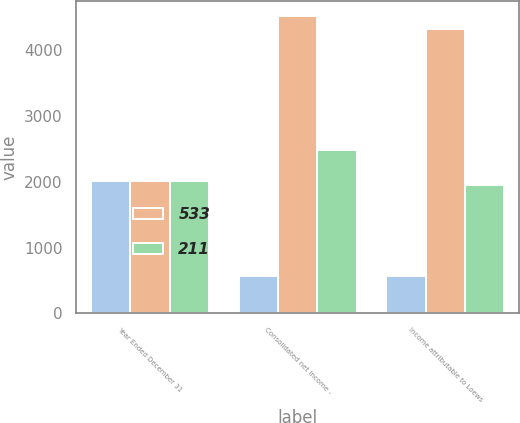<chart> <loc_0><loc_0><loc_500><loc_500><stacked_bar_chart><ecel><fcel>Year Ended December 31<fcel>Consolidated net income -<fcel>Income attributable to Loews<nl><fcel>nan<fcel>2009<fcel>564<fcel>564<nl><fcel>533<fcel>2008<fcel>4530<fcel>4319<nl><fcel>211<fcel>2007<fcel>2488<fcel>1955<nl></chart> 